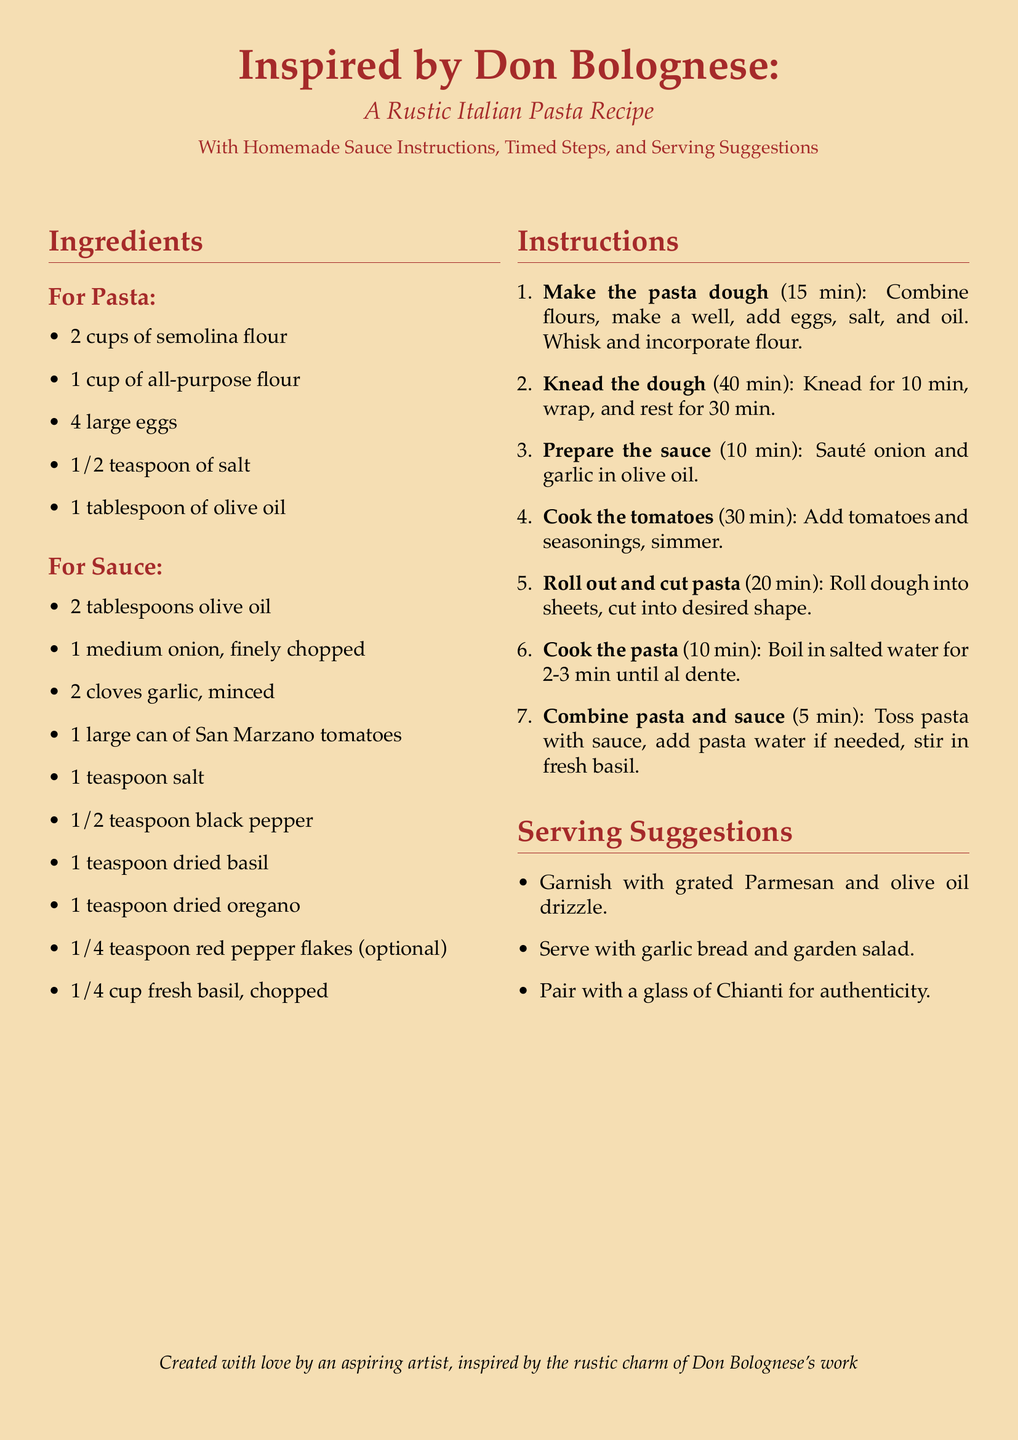What type of flour is used for pasta? The recipe specifies semolina flour and all-purpose flour as ingredients for the pasta.
Answer: semolina flour and all-purpose flour How many large eggs are needed? The document lists 4 large eggs as part of the ingredients for making the pasta.
Answer: 4 What is the total time required to make the pasta dough? The recipe indicates that making the pasta dough takes 15 minutes.
Answer: 15 min What ingredient is optional in the sauce? The recipe mentions red pepper flakes as an optional ingredient.
Answer: red pepper flakes What is paired with the dish for authenticity? The document suggests pairing the dish with a glass of Chianti.
Answer: a glass of Chianti What is the first step in making the pasta? The document states the first step is to make the pasta dough.
Answer: Make the pasta dough How long should the dough rest after kneading? The recipe specifies that the dough should rest for 30 minutes after kneading.
Answer: 30 min What should be used to garnish the dish? The recipe recommends garnishing with grated Parmesan.
Answer: grated Parmesan 